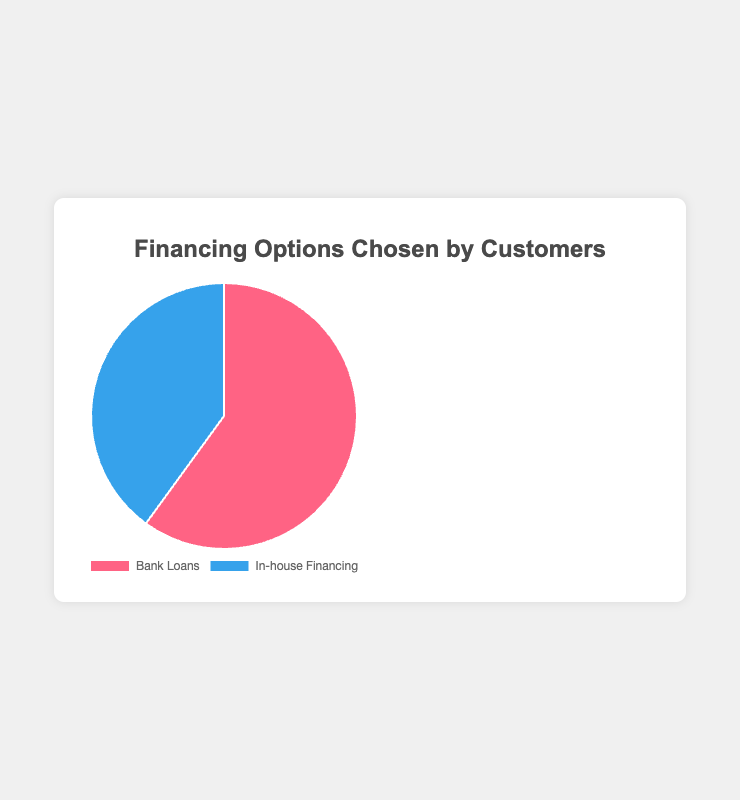what financing option do the majority of customers choose? The pie chart shows that the majority of customers choose bank loans, which accounts for 60% of the financing options.
Answer: Bank loans What percentage of customers choose in-house financing? The pie chart indicates that 40% of customers choose in-house financing.
Answer: 40% Is the proportion of customers choosing bank loans greater than those choosing in-house financing? Yes, the pie chart shows that 60% of customers choose bank loans, which is greater than the 40% who choose in-house financing.
Answer: Yes By how many percentage points do bank loans surpass in-house financing? The difference between the 60% for bank loans and the 40% for in-house financing is 20 percentage points.
Answer: 20 percentage points If you combine the percentages of both financing options, what is the total percentage? Adding the percentages, 60% for bank loans and 40% for in-house financing, gives a total of 100%.
Answer: 100% Considering the chart, if there were 1000 customers, how many would choose in-house financing? With 40% of customers choosing in-house financing out of 1000, there would be 0.40 x 1000 = 400 customers choosing in-house financing.
Answer: 400 customers Which color represents the bank loans in the pie chart? The pie chart uses red to represent bank loans.
Answer: Red Is the section representing in-house financing larger or smaller than that representing bank loans on the pie chart? The section representing in-house financing is smaller than the section representing bank loans, as 40% is less than 60%.
Answer: Smaller What is the difference in customer percentage between the two financing options? The difference in percentage between bank loans (60%) and in-house financing (40%) is 20%.
Answer: 20% What financing option does the chart show in blue? The pie chart shows in-house financing in blue.
Answer: In-house financing 